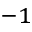Convert formula to latex. <formula><loc_0><loc_0><loc_500><loc_500>^ { - 1 }</formula> 